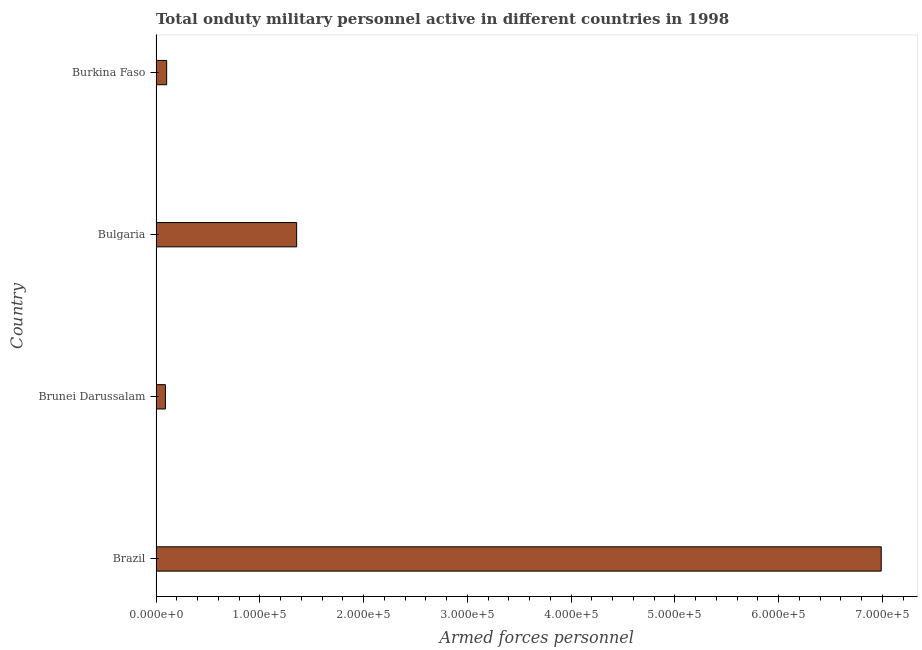Does the graph contain any zero values?
Keep it short and to the point. No. What is the title of the graph?
Your answer should be very brief. Total onduty military personnel active in different countries in 1998. What is the label or title of the X-axis?
Your response must be concise. Armed forces personnel. What is the label or title of the Y-axis?
Provide a short and direct response. Country. What is the number of armed forces personnel in Brunei Darussalam?
Keep it short and to the point. 9050. Across all countries, what is the maximum number of armed forces personnel?
Provide a short and direct response. 6.99e+05. Across all countries, what is the minimum number of armed forces personnel?
Make the answer very short. 9050. In which country was the number of armed forces personnel minimum?
Keep it short and to the point. Brunei Darussalam. What is the sum of the number of armed forces personnel?
Offer a terse response. 8.54e+05. What is the difference between the number of armed forces personnel in Bulgaria and Burkina Faso?
Provide a succinct answer. 1.25e+05. What is the average number of armed forces personnel per country?
Your answer should be very brief. 2.13e+05. What is the median number of armed forces personnel?
Keep it short and to the point. 7.29e+04. In how many countries, is the number of armed forces personnel greater than 340000 ?
Your answer should be very brief. 1. What is the ratio of the number of armed forces personnel in Brazil to that in Bulgaria?
Make the answer very short. 5.16. What is the difference between the highest and the second highest number of armed forces personnel?
Provide a short and direct response. 5.63e+05. What is the difference between the highest and the lowest number of armed forces personnel?
Provide a succinct answer. 6.90e+05. In how many countries, is the number of armed forces personnel greater than the average number of armed forces personnel taken over all countries?
Your answer should be compact. 1. How many bars are there?
Make the answer very short. 4. Are all the bars in the graph horizontal?
Keep it short and to the point. Yes. What is the difference between two consecutive major ticks on the X-axis?
Make the answer very short. 1.00e+05. What is the Armed forces personnel of Brazil?
Your answer should be compact. 6.99e+05. What is the Armed forces personnel of Brunei Darussalam?
Keep it short and to the point. 9050. What is the Armed forces personnel in Bulgaria?
Your answer should be very brief. 1.36e+05. What is the Armed forces personnel of Burkina Faso?
Offer a terse response. 1.02e+04. What is the difference between the Armed forces personnel in Brazil and Brunei Darussalam?
Offer a terse response. 6.90e+05. What is the difference between the Armed forces personnel in Brazil and Bulgaria?
Provide a succinct answer. 5.63e+05. What is the difference between the Armed forces personnel in Brazil and Burkina Faso?
Offer a terse response. 6.89e+05. What is the difference between the Armed forces personnel in Brunei Darussalam and Bulgaria?
Provide a succinct answer. -1.26e+05. What is the difference between the Armed forces personnel in Brunei Darussalam and Burkina Faso?
Your response must be concise. -1200. What is the difference between the Armed forces personnel in Bulgaria and Burkina Faso?
Offer a very short reply. 1.25e+05. What is the ratio of the Armed forces personnel in Brazil to that in Brunei Darussalam?
Keep it short and to the point. 77.22. What is the ratio of the Armed forces personnel in Brazil to that in Bulgaria?
Your response must be concise. 5.16. What is the ratio of the Armed forces personnel in Brazil to that in Burkina Faso?
Offer a terse response. 68.18. What is the ratio of the Armed forces personnel in Brunei Darussalam to that in Bulgaria?
Give a very brief answer. 0.07. What is the ratio of the Armed forces personnel in Brunei Darussalam to that in Burkina Faso?
Your answer should be compact. 0.88. What is the ratio of the Armed forces personnel in Bulgaria to that in Burkina Faso?
Provide a short and direct response. 13.22. 